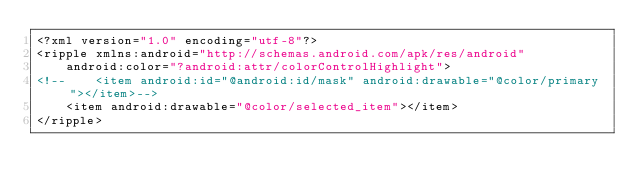<code> <loc_0><loc_0><loc_500><loc_500><_XML_><?xml version="1.0" encoding="utf-8"?>
<ripple xmlns:android="http://schemas.android.com/apk/res/android"
    android:color="?android:attr/colorControlHighlight">
<!--    <item android:id="@android:id/mask" android:drawable="@color/primary"></item>-->
    <item android:drawable="@color/selected_item"></item>
</ripple></code> 